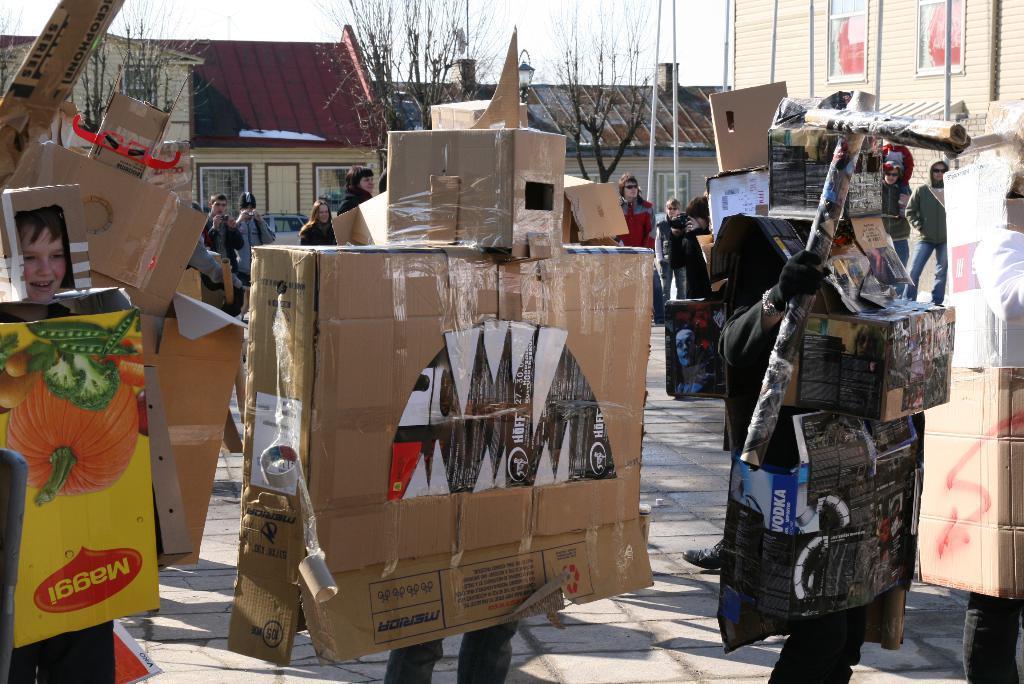Could you give a brief overview of what you see in this image? In the center of the image we can see a few people are standing and they are holding some objects. And we can see they are in different costumes. And the right side person is smiling. In the background, we can see the sky, clouds, trees, buildings, poles, banners,one vehicle, few people are standing and few other objects. 